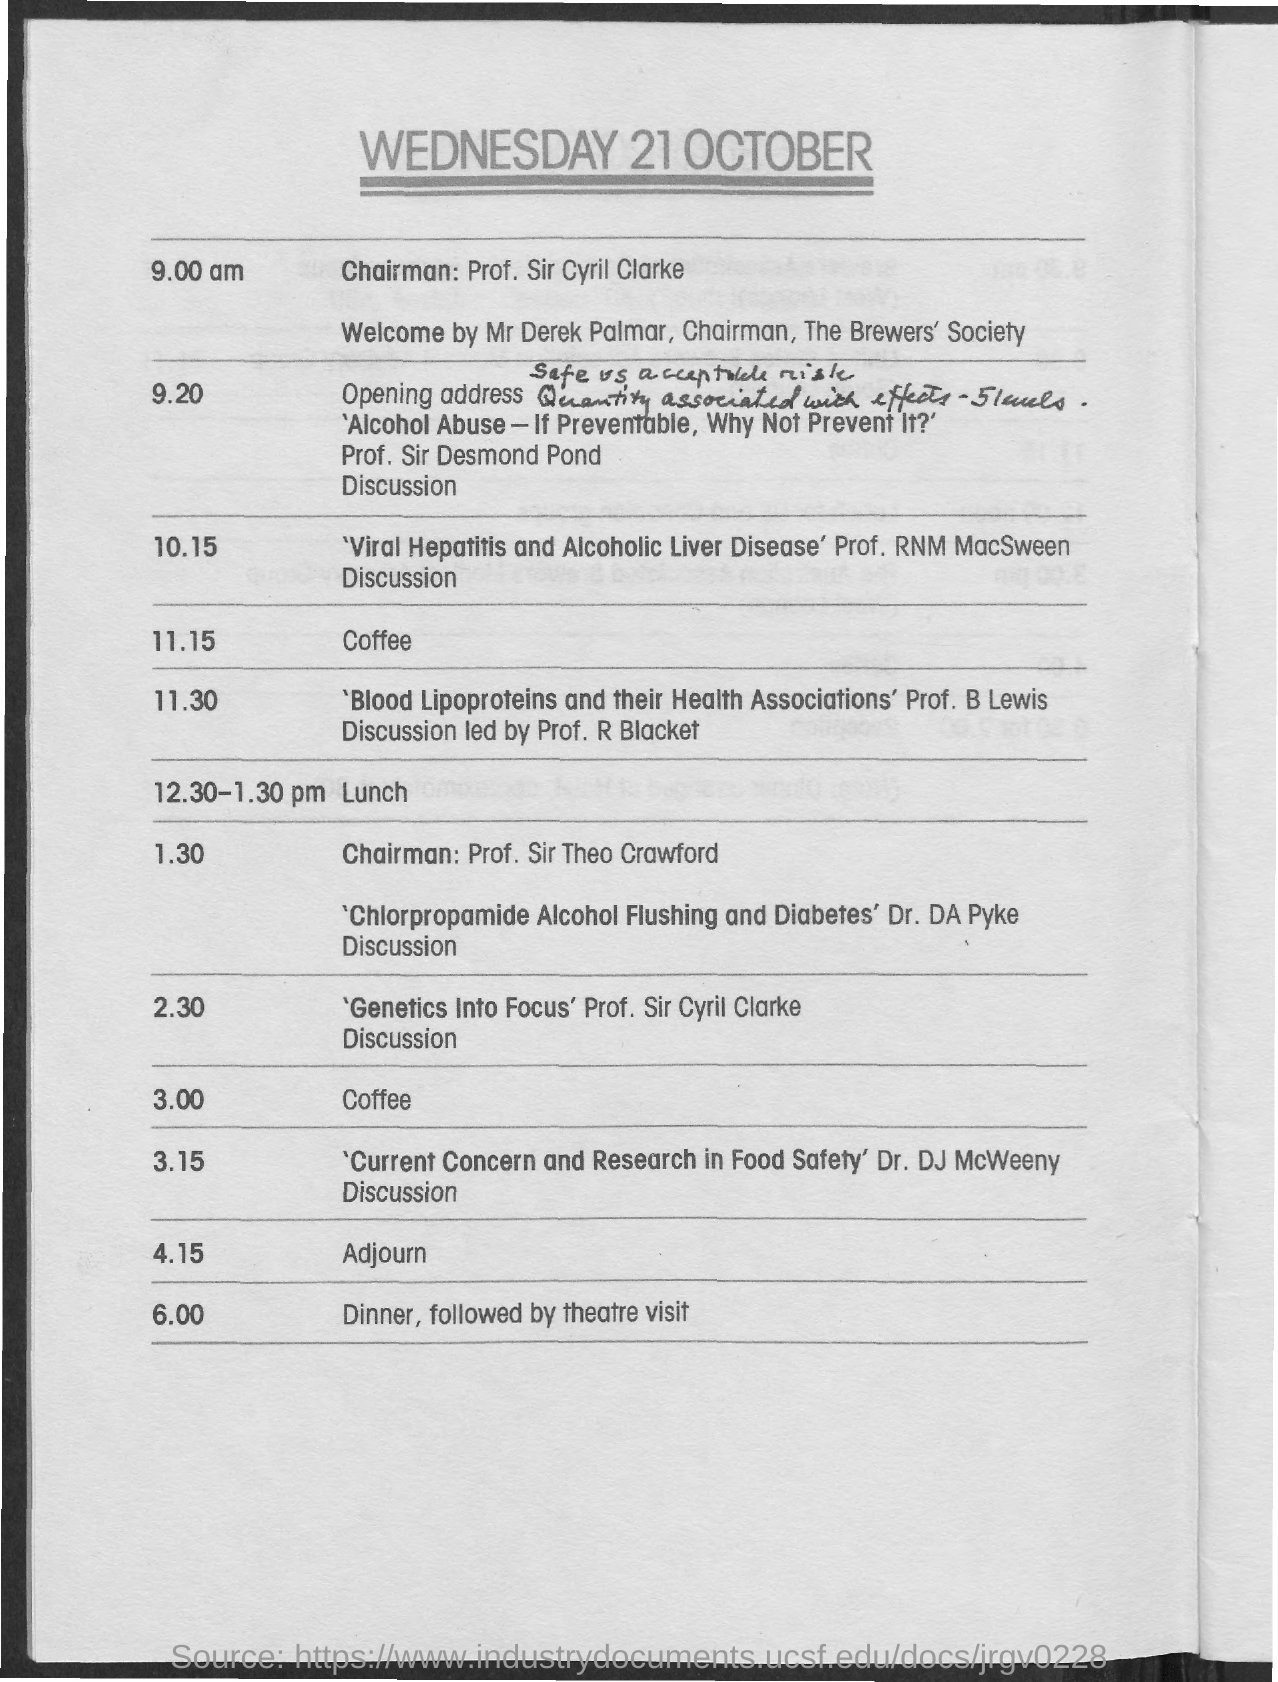Mention a couple of crucial points in this snapshot. The time scheduled for lunch is from 12:30 PM to 1:30 PM. Prof. RNM MacSween led a discussion on the topics of viral hepatitis and alcoholic liver disease. It has been announced that Mr. Derek Palmar will be delivering the Welcome speech. The meeting was adjourned at 4:15 PM. Prof. Sir Cyril Clarke is currently engaged in a discussion about genetics. 